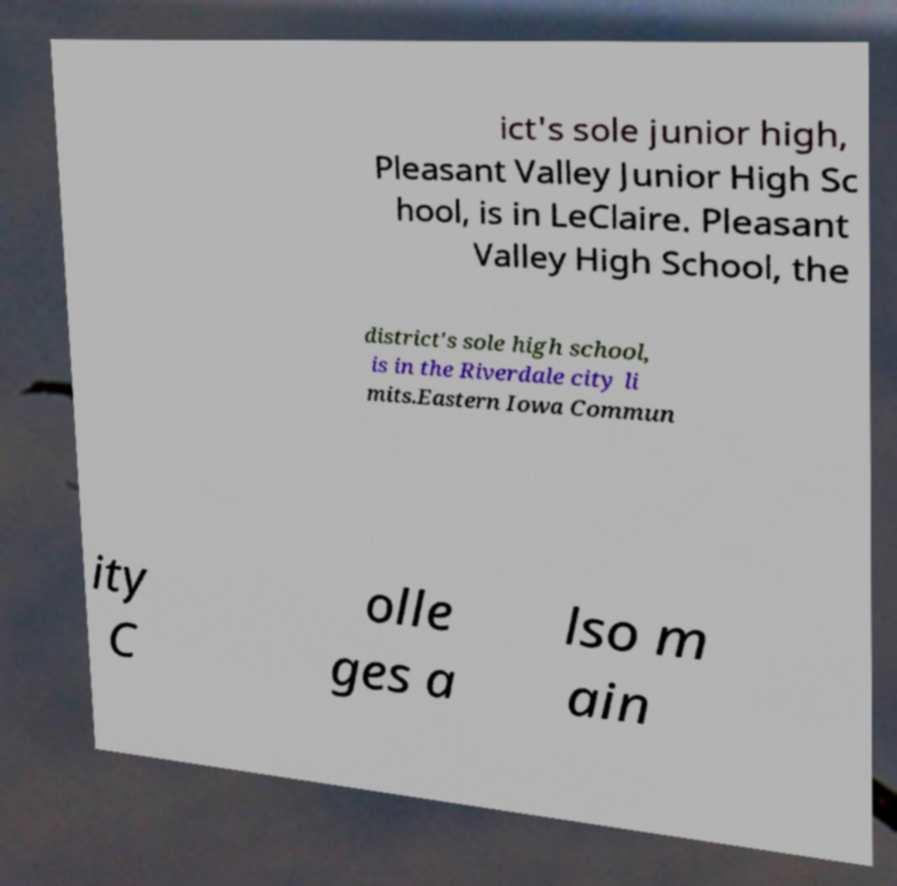For documentation purposes, I need the text within this image transcribed. Could you provide that? ict's sole junior high, Pleasant Valley Junior High Sc hool, is in LeClaire. Pleasant Valley High School, the district's sole high school, is in the Riverdale city li mits.Eastern Iowa Commun ity C olle ges a lso m ain 